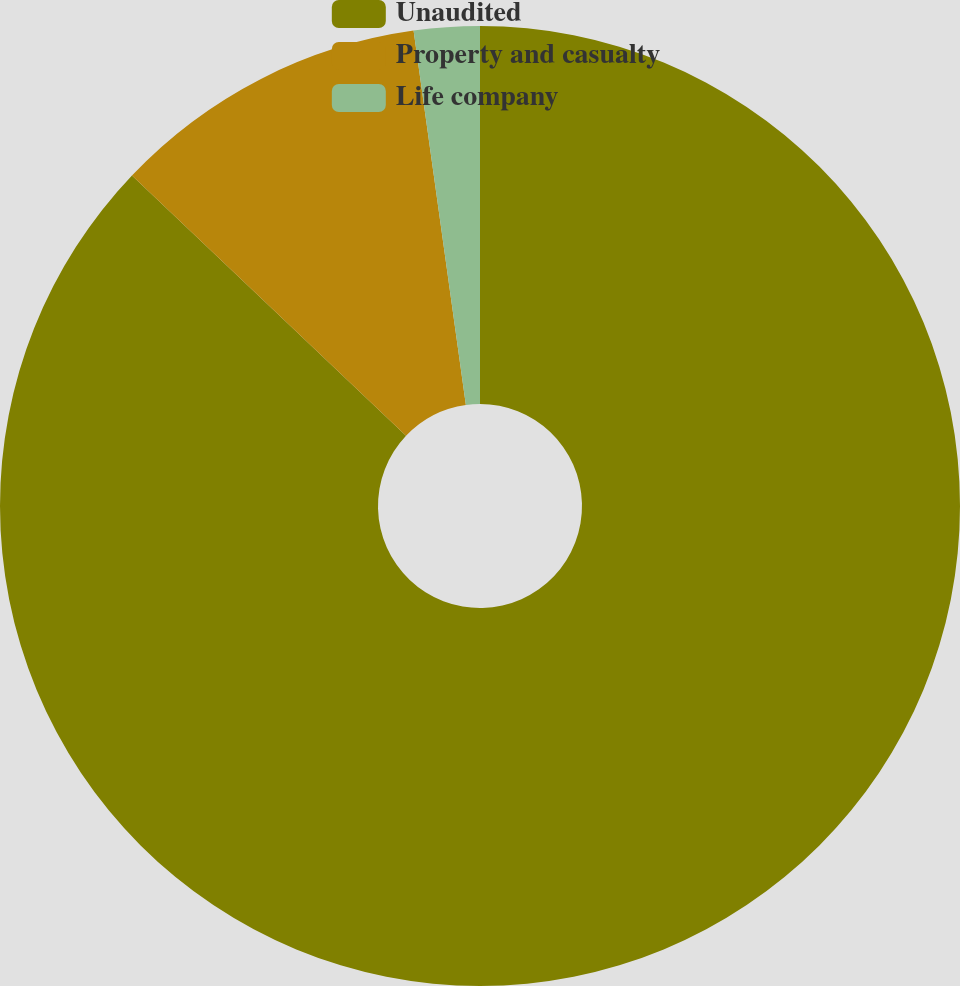Convert chart to OTSL. <chart><loc_0><loc_0><loc_500><loc_500><pie_chart><fcel>Unaudited<fcel>Property and casualty<fcel>Life company<nl><fcel>87.09%<fcel>10.7%<fcel>2.21%<nl></chart> 